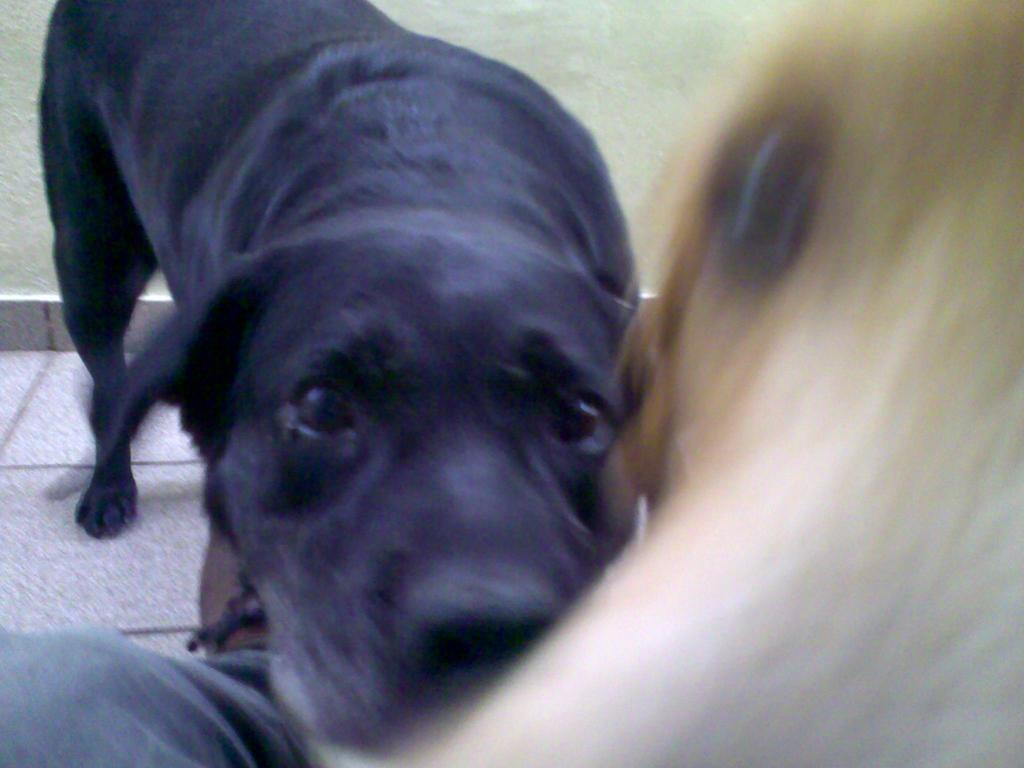What type of animal is in the image? There is a dog in the image. What color is the dog? The dog is black in color. How is the dog depicted in the image? The dog is blurred in the image. What else can be seen in the image besides the dog? There is a leg of a person and a path visible in the image. How many trucks are parked next to the dog in the image? There are no trucks present in the image; it only features a dog, a leg of a person, and a path. 